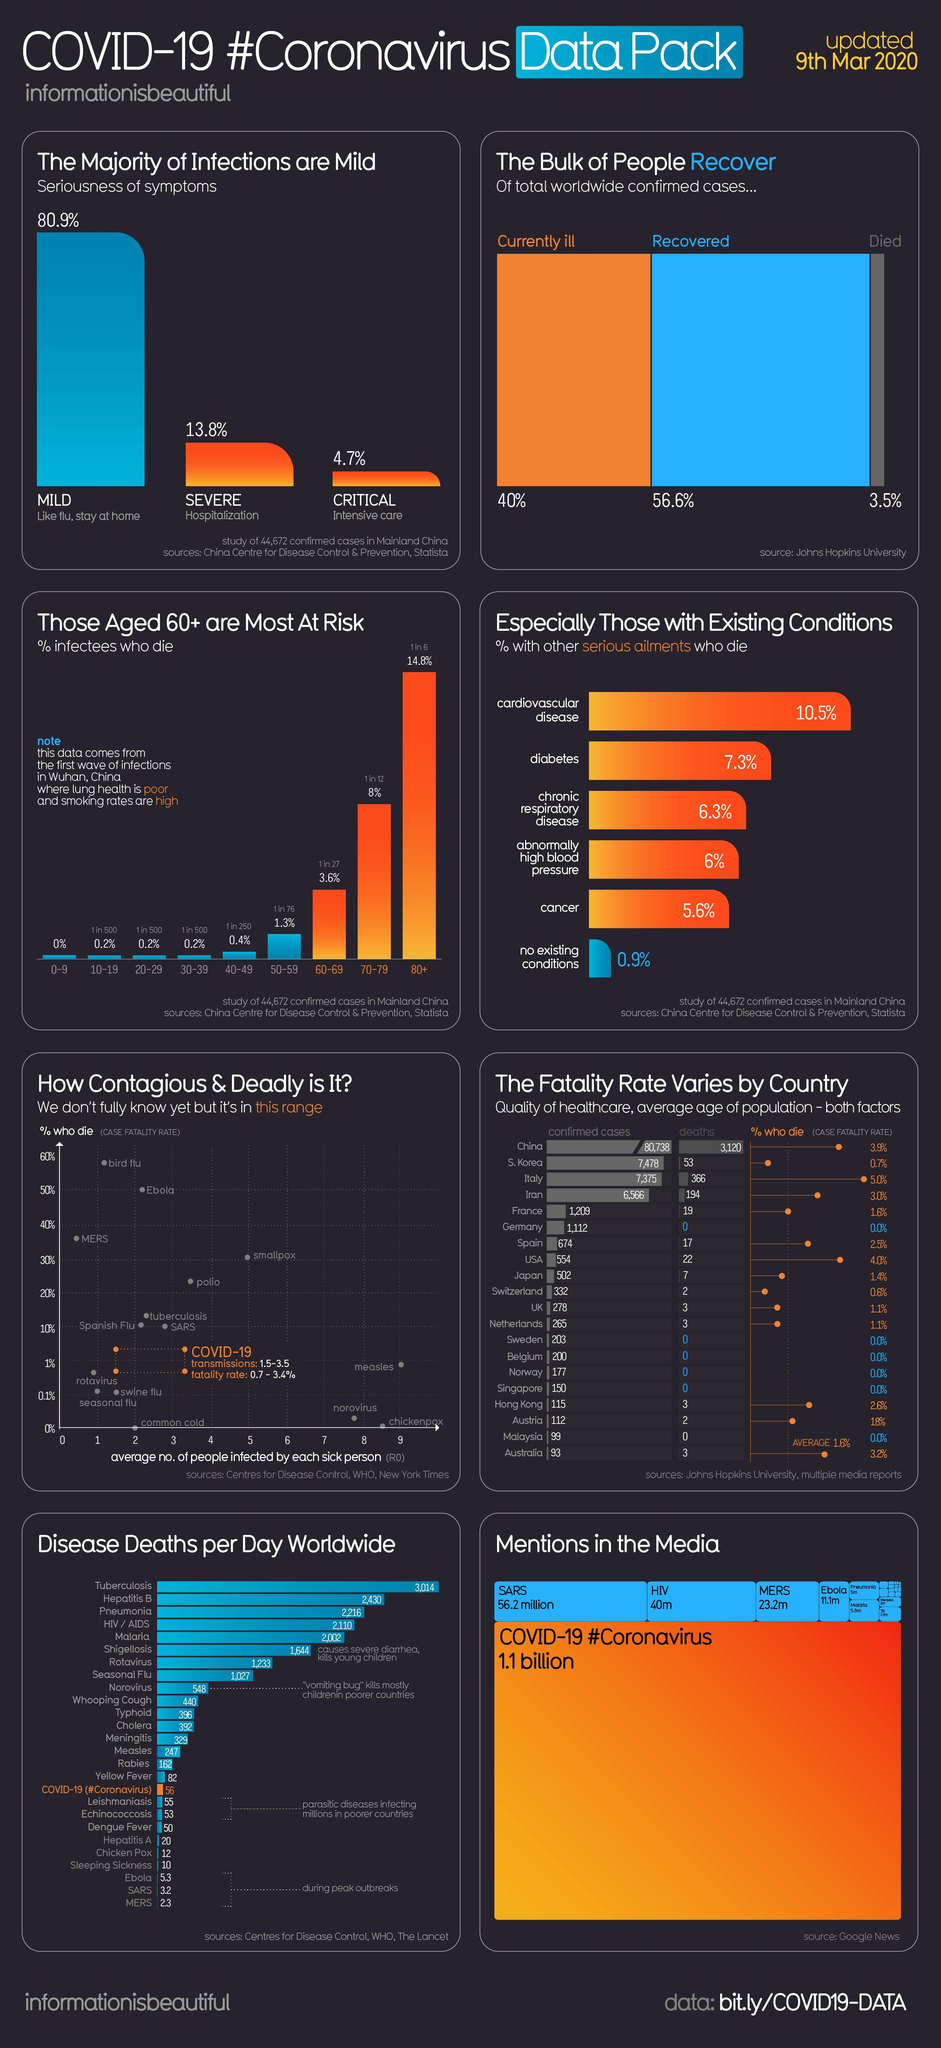What percent of people die from corona virus due to cardiovascular disease and cancer?
Answer the question with a short phrase. 16.1% 